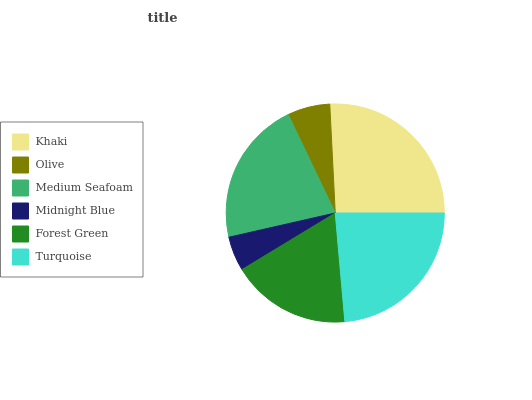Is Midnight Blue the minimum?
Answer yes or no. Yes. Is Khaki the maximum?
Answer yes or no. Yes. Is Olive the minimum?
Answer yes or no. No. Is Olive the maximum?
Answer yes or no. No. Is Khaki greater than Olive?
Answer yes or no. Yes. Is Olive less than Khaki?
Answer yes or no. Yes. Is Olive greater than Khaki?
Answer yes or no. No. Is Khaki less than Olive?
Answer yes or no. No. Is Medium Seafoam the high median?
Answer yes or no. Yes. Is Forest Green the low median?
Answer yes or no. Yes. Is Forest Green the high median?
Answer yes or no. No. Is Olive the low median?
Answer yes or no. No. 